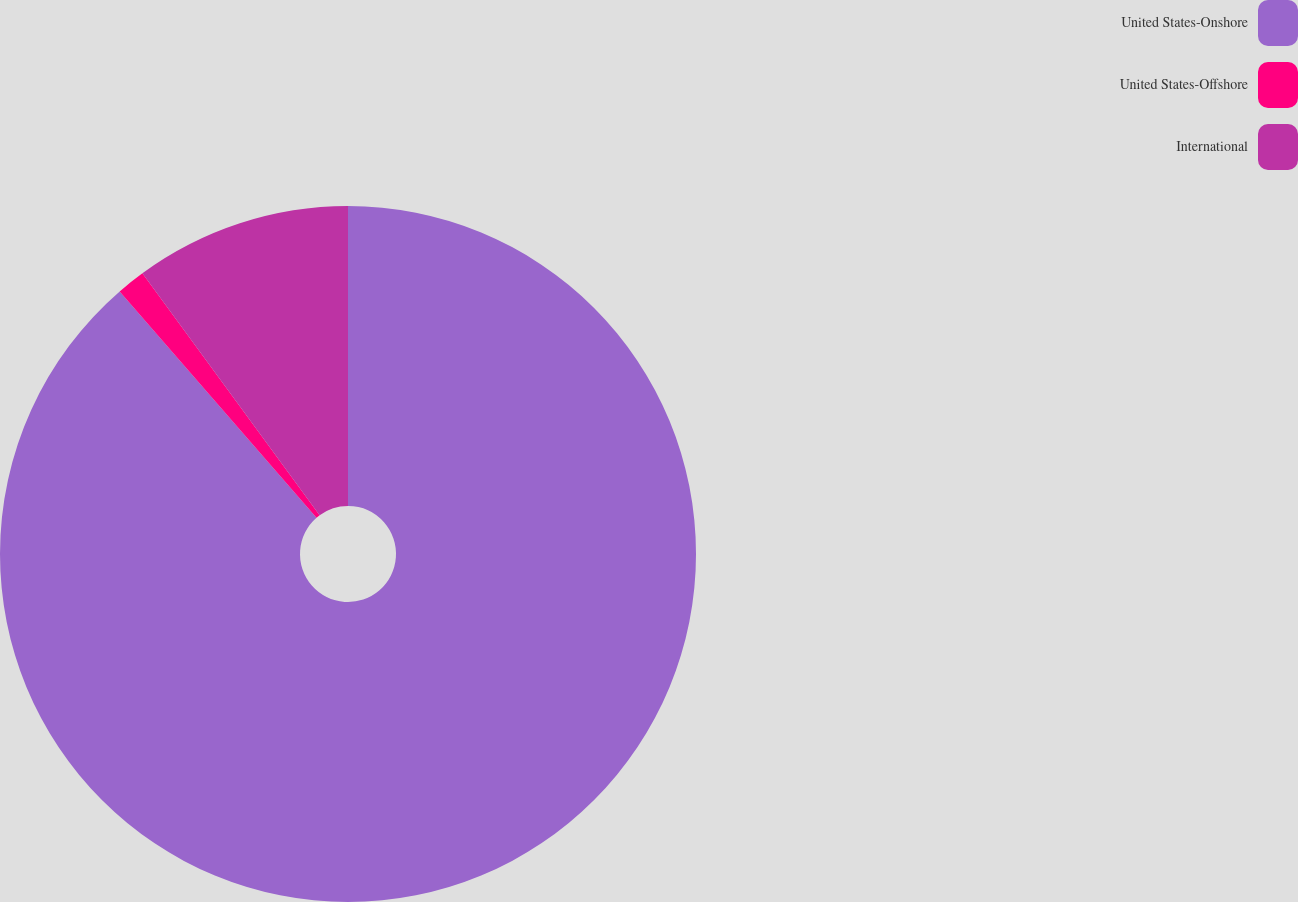Convert chart. <chart><loc_0><loc_0><loc_500><loc_500><pie_chart><fcel>United States-Onshore<fcel>United States-Offshore<fcel>International<nl><fcel>88.61%<fcel>1.33%<fcel>10.06%<nl></chart> 